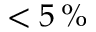Convert formula to latex. <formula><loc_0><loc_0><loc_500><loc_500>< 5 \, \%</formula> 